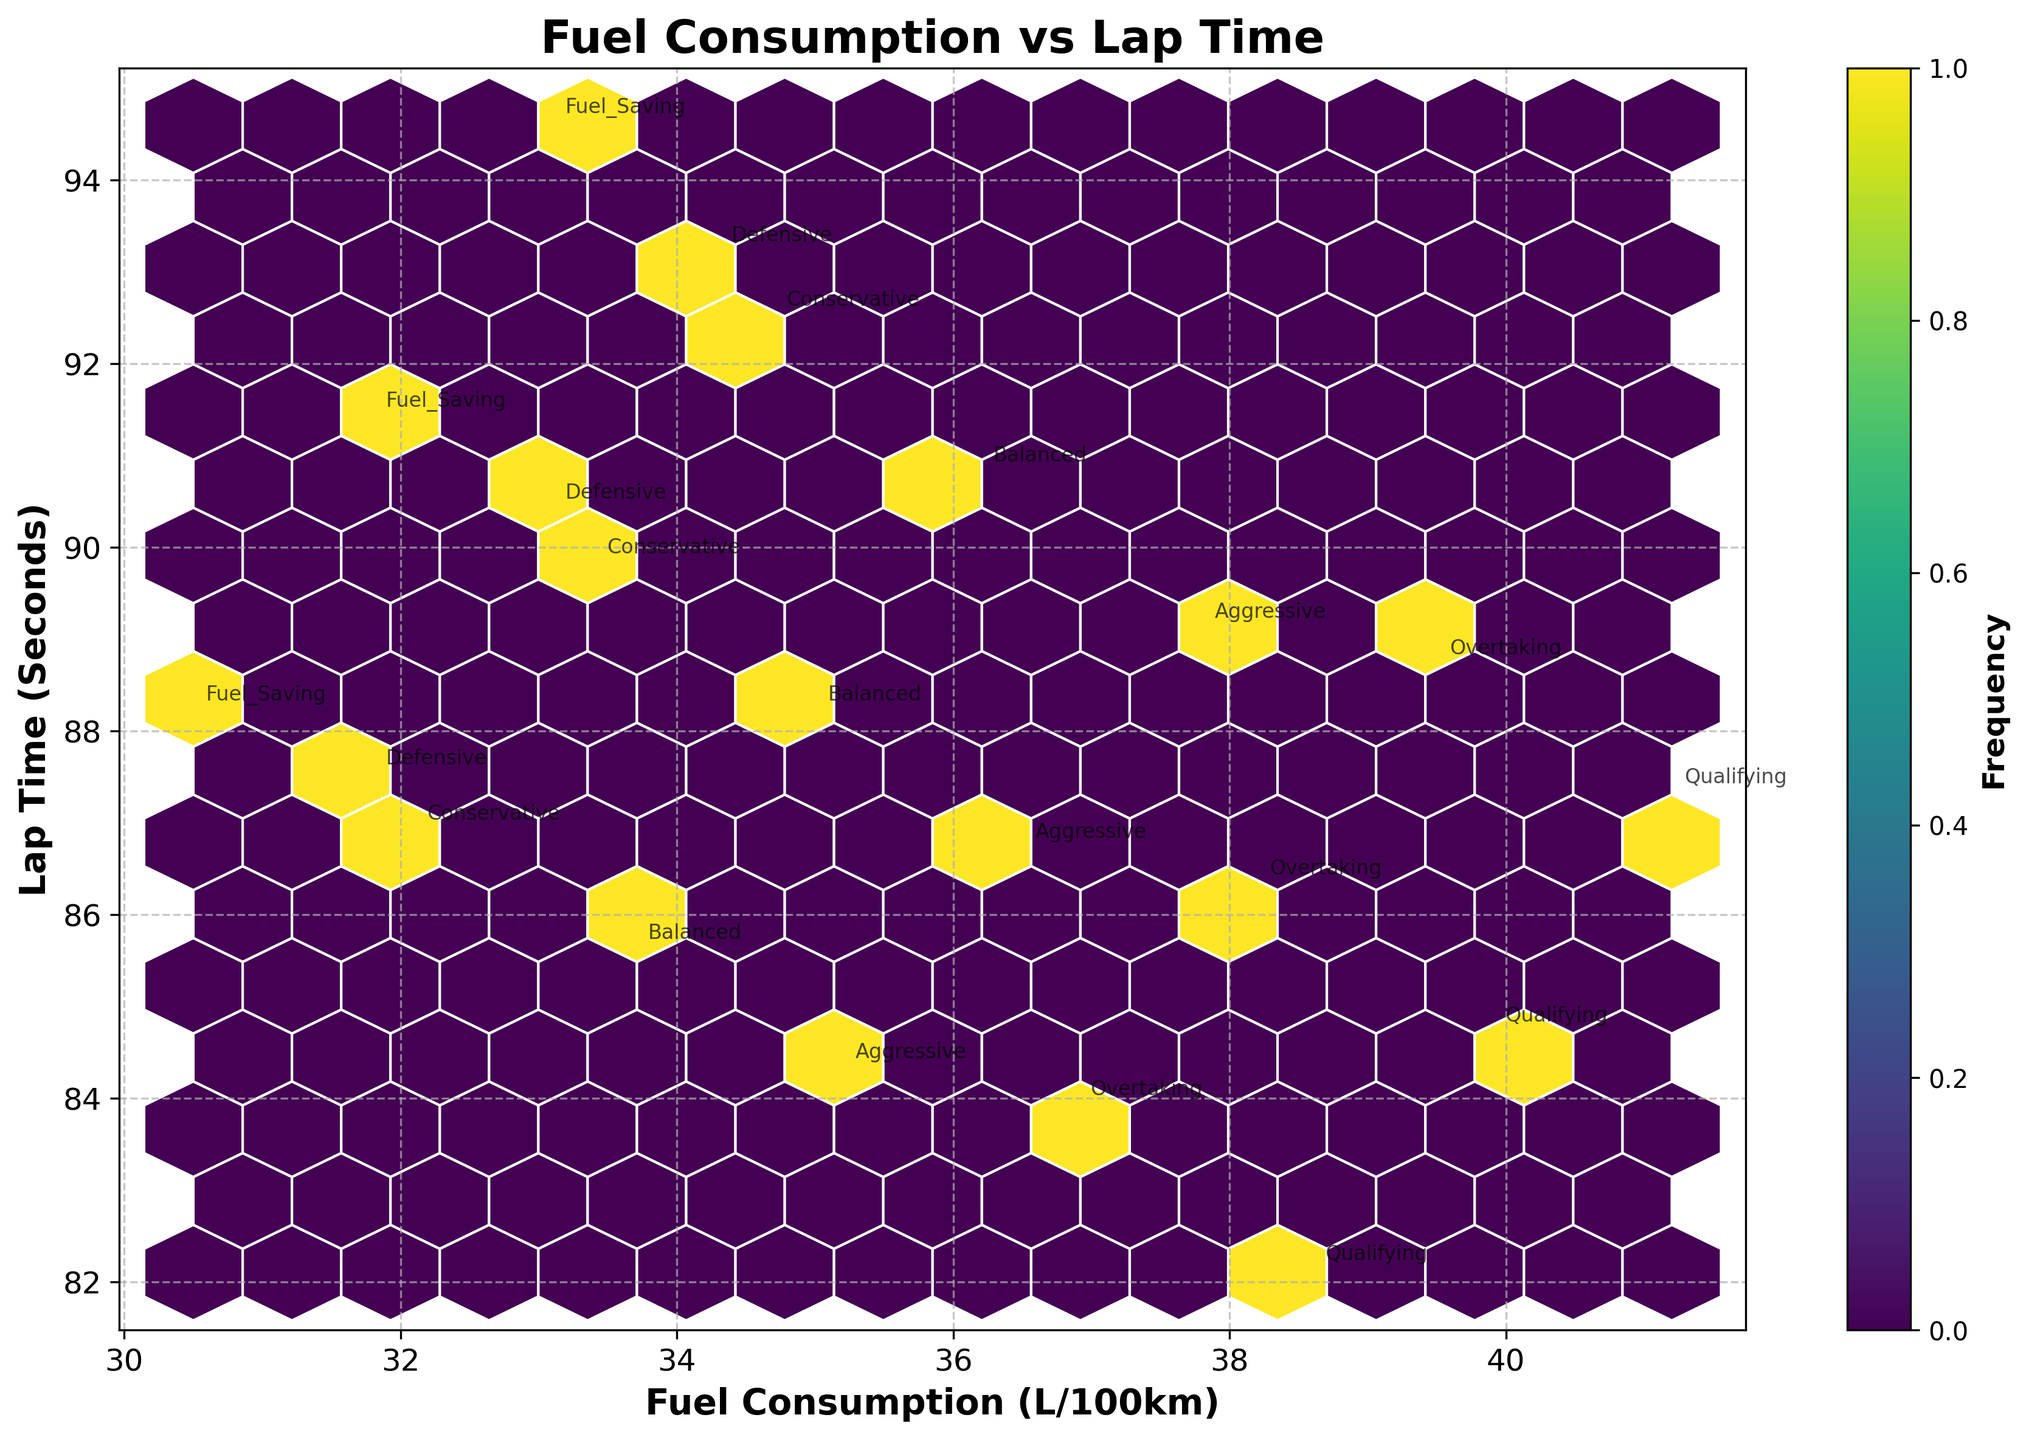What is the title of the plot? The title of the plot is usually located at the top of the figure in a larger, bold font.
Answer: Fuel Consumption vs Lap Time What is the color scheme used in the hexbin plot? The hexbin plot uses a color scheme that varies from dark to light, representing the frequency of data points.
Answer: Viridis What are the axes labels on the plot? The axes labels are typically found along the x-axis and y-axis, indicating what the data represents.
Answer: Fuel Consumption (L/100km) and Lap Time (Seconds) Which driving style has the highest fuel consumption? To find the driving style with the highest fuel consumption, look for the data point with the highest x-value and check the corresponding annotation.
Answer: Qualifying Which driving style is associated with the lowest lap time? To identify the driving style with the lowest lap time, look for the data point with the lowest y-value and check the corresponding annotation.
Answer: Qualifying What is the range of fuel consumption values in the plot? To determine the range of fuel consumption values, find the minimum and maximum values on the x-axis. The lowest x-value starts at 30.5 and the highest is 41.2. Subtracting these gives the range.
Answer: 10.7 L/100km Which driving styles have similar fuel consumption and lap times under mixed track conditions? Look for data points clustered close together along both axes that are annotated with the same track condition.
Answer: Aggressive, Balanced, and Conservative Are there more data points with high fuel consumption and high lap times or low fuel consumption and low lap times? Observe the density of hexagons in the top right (high fuel/high lap) and bottom left (low fuel/low lap) sections of the plot.
Answer: High fuel consumption and high lap times Which driving style under dry conditions has the smallest lap time? Look for the data point with the lowest y-value that is annotated as 'Dry' and note the driving style.
Answer: Qualifying Is there a clear relationship between fuel consumption and lap time depicted in the plot? Inspect the overall distribution of the hexagons. If the hexagons trend upward or downward, there is a relationship.
Answer: Yes, higher fuel consumption often correlates with lower lap times 